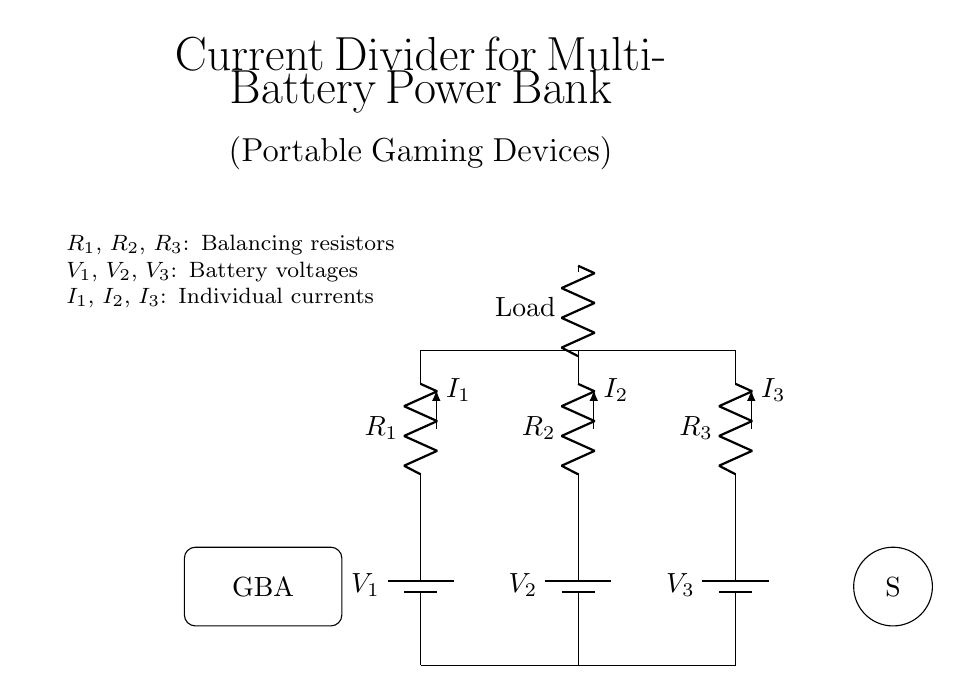What are the components in the circuit? The components include three batteries, three resistors, and a load, as labeled in the diagram.
Answer: Batteries, resistors, load What is the purpose of the resistors in this circuit? The resistors are used to balance the current flow from each battery to ensure stable operation of the load.
Answer: Current balance What is the total number of batteries used? The circuit diagram shows three batteries connected in parallel.
Answer: Three What is the relationship between the load and the current in the circuit? The load receives current from the batteries, which is divided among the resistors to ensure that the total current supplied is properly balanced.
Answer: Divided current How can the current through each resistor be determined? The current through each resistor can be determined using Ohm's Law and the voltage of each battery, along with the resistance value of each resistor. It requires calculating the voltage drop across each resistor.
Answer: Ohm's Law Which component represents the load in this circuit? The load is represented on the circuit diagram as a resistor, labeled simply as "Load."
Answer: Load What is the role of the battery voltages in current flow? The battery voltages provide the necessary potential difference to drive current through the connected resistors to the load, contributing to the operation of the device.
Answer: Provide potential difference 